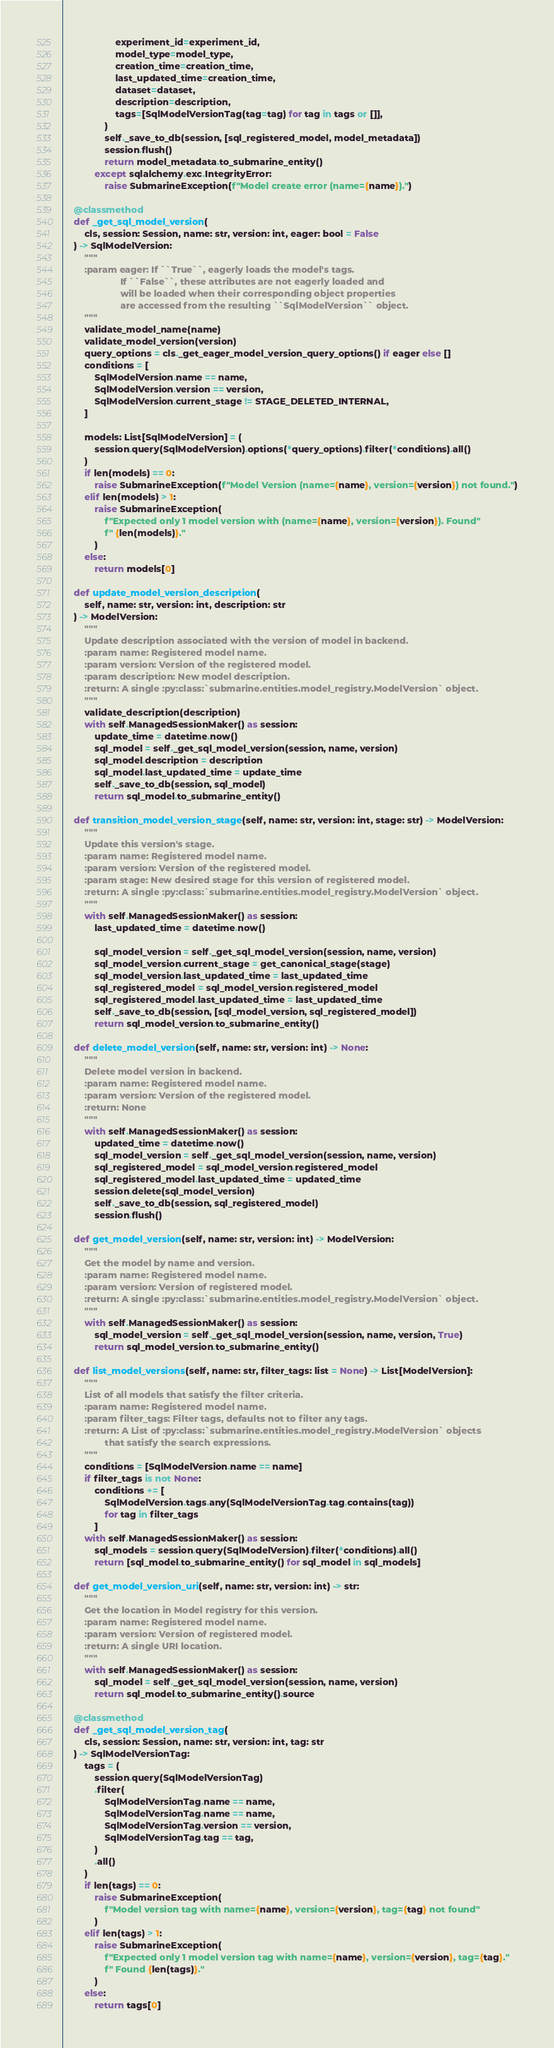<code> <loc_0><loc_0><loc_500><loc_500><_Python_>                    experiment_id=experiment_id,
                    model_type=model_type,
                    creation_time=creation_time,
                    last_updated_time=creation_time,
                    dataset=dataset,
                    description=description,
                    tags=[SqlModelVersionTag(tag=tag) for tag in tags or []],
                )
                self._save_to_db(session, [sql_registered_model, model_metadata])
                session.flush()
                return model_metadata.to_submarine_entity()
            except sqlalchemy.exc.IntegrityError:
                raise SubmarineException(f"Model create error (name={name}).")

    @classmethod
    def _get_sql_model_version(
        cls, session: Session, name: str, version: int, eager: bool = False
    ) -> SqlModelVersion:
        """
        :param eager: If ``True``, eagerly loads the model's tags.
                      If ``False``, these attributes are not eagerly loaded and
                      will be loaded when their corresponding object properties
                      are accessed from the resulting ``SqlModelVersion`` object.
        """
        validate_model_name(name)
        validate_model_version(version)
        query_options = cls._get_eager_model_version_query_options() if eager else []
        conditions = [
            SqlModelVersion.name == name,
            SqlModelVersion.version == version,
            SqlModelVersion.current_stage != STAGE_DELETED_INTERNAL,
        ]

        models: List[SqlModelVersion] = (
            session.query(SqlModelVersion).options(*query_options).filter(*conditions).all()
        )
        if len(models) == 0:
            raise SubmarineException(f"Model Version (name={name}, version={version}) not found.")
        elif len(models) > 1:
            raise SubmarineException(
                f"Expected only 1 model version with (name={name}, version={version}). Found"
                f" {len(models)}."
            )
        else:
            return models[0]

    def update_model_version_description(
        self, name: str, version: int, description: str
    ) -> ModelVersion:
        """
        Update description associated with the version of model in backend.
        :param name: Registered model name.
        :param version: Version of the registered model.
        :param description: New model description.
        :return: A single :py:class:`submarine.entities.model_registry.ModelVersion` object.
        """
        validate_description(description)
        with self.ManagedSessionMaker() as session:
            update_time = datetime.now()
            sql_model = self._get_sql_model_version(session, name, version)
            sql_model.description = description
            sql_model.last_updated_time = update_time
            self._save_to_db(session, sql_model)
            return sql_model.to_submarine_entity()

    def transition_model_version_stage(self, name: str, version: int, stage: str) -> ModelVersion:
        """
        Update this version's stage.
        :param name: Registered model name.
        :param version: Version of the registered model.
        :param stage: New desired stage for this version of registered model.
        :return: A single :py:class:`submarine.entities.model_registry.ModelVersion` object.
        """
        with self.ManagedSessionMaker() as session:
            last_updated_time = datetime.now()

            sql_model_version = self._get_sql_model_version(session, name, version)
            sql_model_version.current_stage = get_canonical_stage(stage)
            sql_model_version.last_updated_time = last_updated_time
            sql_registered_model = sql_model_version.registered_model
            sql_registered_model.last_updated_time = last_updated_time
            self._save_to_db(session, [sql_model_version, sql_registered_model])
            return sql_model_version.to_submarine_entity()

    def delete_model_version(self, name: str, version: int) -> None:
        """
        Delete model version in backend.
        :param name: Registered model name.
        :param version: Version of the registered model.
        :return: None
        """
        with self.ManagedSessionMaker() as session:
            updated_time = datetime.now()
            sql_model_version = self._get_sql_model_version(session, name, version)
            sql_registered_model = sql_model_version.registered_model
            sql_registered_model.last_updated_time = updated_time
            session.delete(sql_model_version)
            self._save_to_db(session, sql_registered_model)
            session.flush()

    def get_model_version(self, name: str, version: int) -> ModelVersion:
        """
        Get the model by name and version.
        :param name: Registered model name.
        :param version: Version of registered model.
        :return: A single :py:class:`submarine.entities.model_registry.ModelVersion` object.
        """
        with self.ManagedSessionMaker() as session:
            sql_model_version = self._get_sql_model_version(session, name, version, True)
            return sql_model_version.to_submarine_entity()

    def list_model_versions(self, name: str, filter_tags: list = None) -> List[ModelVersion]:
        """
        List of all models that satisfy the filter criteria.
        :param name: Registered model name.
        :param filter_tags: Filter tags, defaults not to filter any tags.
        :return: A List of :py:class:`submarine.entities.model_registry.ModelVersion` objects
                that satisfy the search expressions.
        """
        conditions = [SqlModelVersion.name == name]
        if filter_tags is not None:
            conditions += [
                SqlModelVersion.tags.any(SqlModelVersionTag.tag.contains(tag))
                for tag in filter_tags
            ]
        with self.ManagedSessionMaker() as session:
            sql_models = session.query(SqlModelVersion).filter(*conditions).all()
            return [sql_model.to_submarine_entity() for sql_model in sql_models]

    def get_model_version_uri(self, name: str, version: int) -> str:
        """
        Get the location in Model registry for this version.
        :param name: Registered model name.
        :param version: Version of registered model.
        :return: A single URI location.
        """
        with self.ManagedSessionMaker() as session:
            sql_model = self._get_sql_model_version(session, name, version)
            return sql_model.to_submarine_entity().source

    @classmethod
    def _get_sql_model_version_tag(
        cls, session: Session, name: str, version: int, tag: str
    ) -> SqlModelVersionTag:
        tags = (
            session.query(SqlModelVersionTag)
            .filter(
                SqlModelVersionTag.name == name,
                SqlModelVersionTag.name == name,
                SqlModelVersionTag.version == version,
                SqlModelVersionTag.tag == tag,
            )
            .all()
        )
        if len(tags) == 0:
            raise SubmarineException(
                f"Model version tag with name={name}, version={version}, tag={tag} not found"
            )
        elif len(tags) > 1:
            raise SubmarineException(
                f"Expected only 1 model version tag with name={name}, version={version}, tag={tag}."
                f" Found {len(tags)}."
            )
        else:
            return tags[0]
</code> 